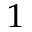Convert formula to latex. <formula><loc_0><loc_0><loc_500><loc_500>^ { 1 }</formula> 